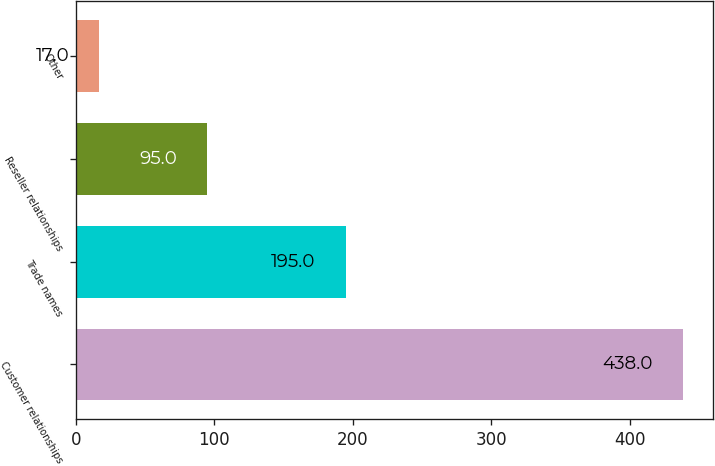Convert chart to OTSL. <chart><loc_0><loc_0><loc_500><loc_500><bar_chart><fcel>Customer relationships<fcel>Trade names<fcel>Reseller relationships<fcel>Other<nl><fcel>438<fcel>195<fcel>95<fcel>17<nl></chart> 